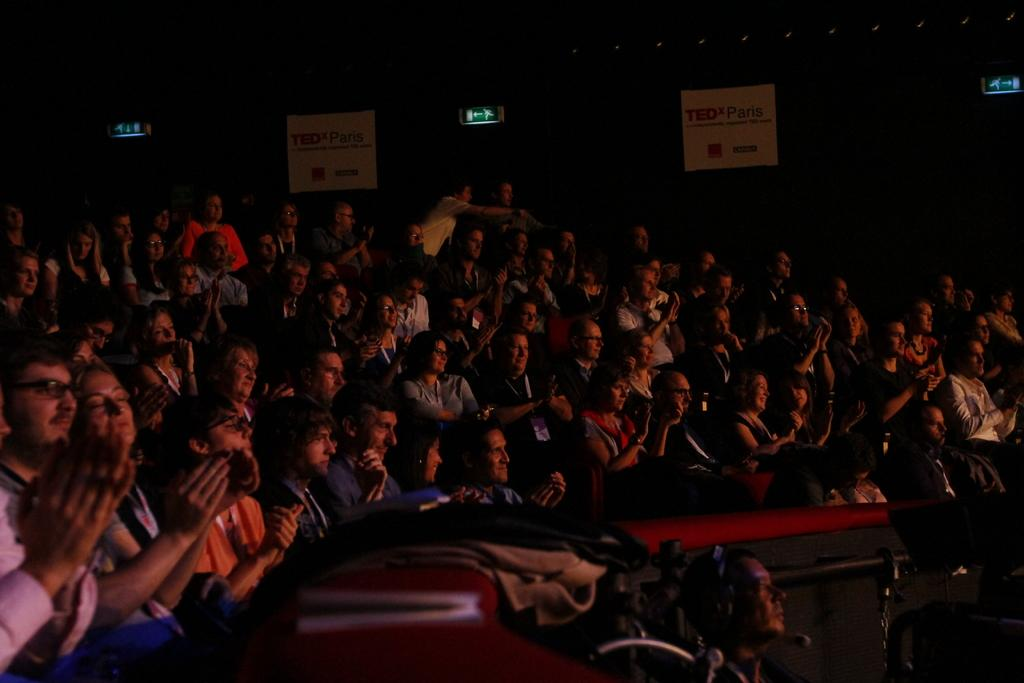How many people are in the image? There are many people in the image. What are the people in the image doing? The people are sitting. Are there any specific actions being performed by the people in the image? Yes, some of the people are clapping. What type of meat can be seen being prepared in the image? There is no meat present in the image; it features people sitting and clapping. 